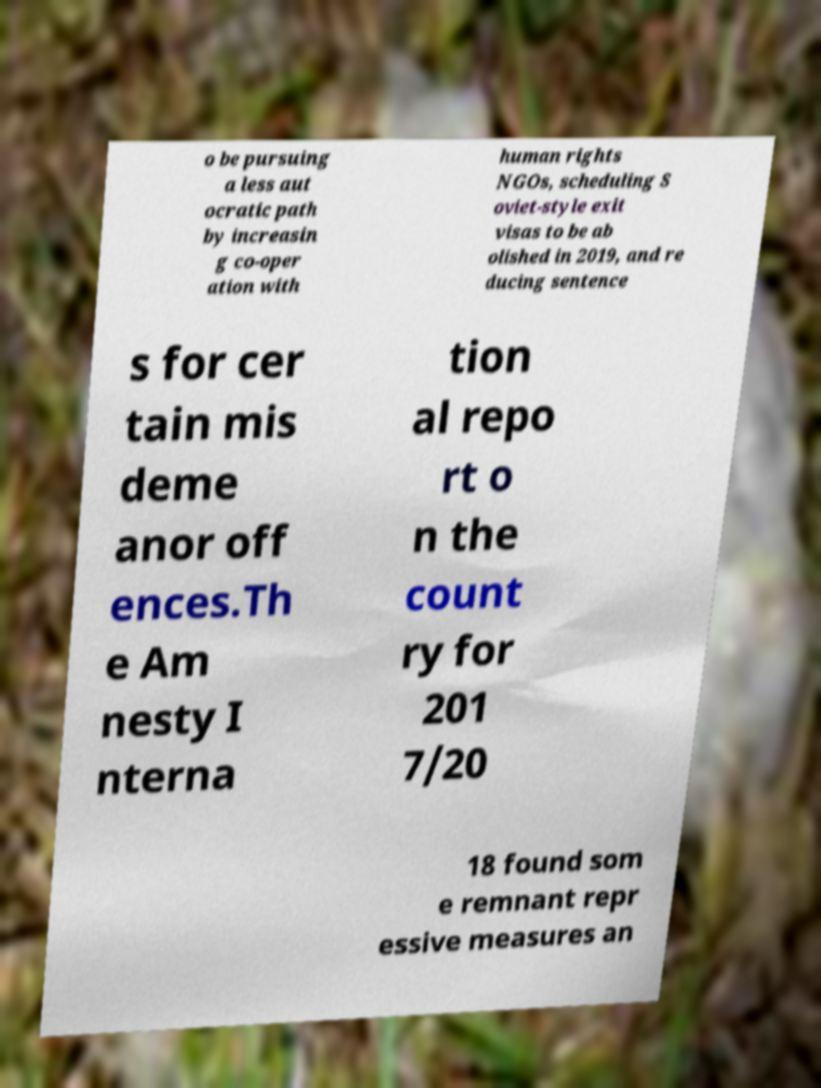There's text embedded in this image that I need extracted. Can you transcribe it verbatim? o be pursuing a less aut ocratic path by increasin g co-oper ation with human rights NGOs, scheduling S oviet-style exit visas to be ab olished in 2019, and re ducing sentence s for cer tain mis deme anor off ences.Th e Am nesty I nterna tion al repo rt o n the count ry for 201 7/20 18 found som e remnant repr essive measures an 